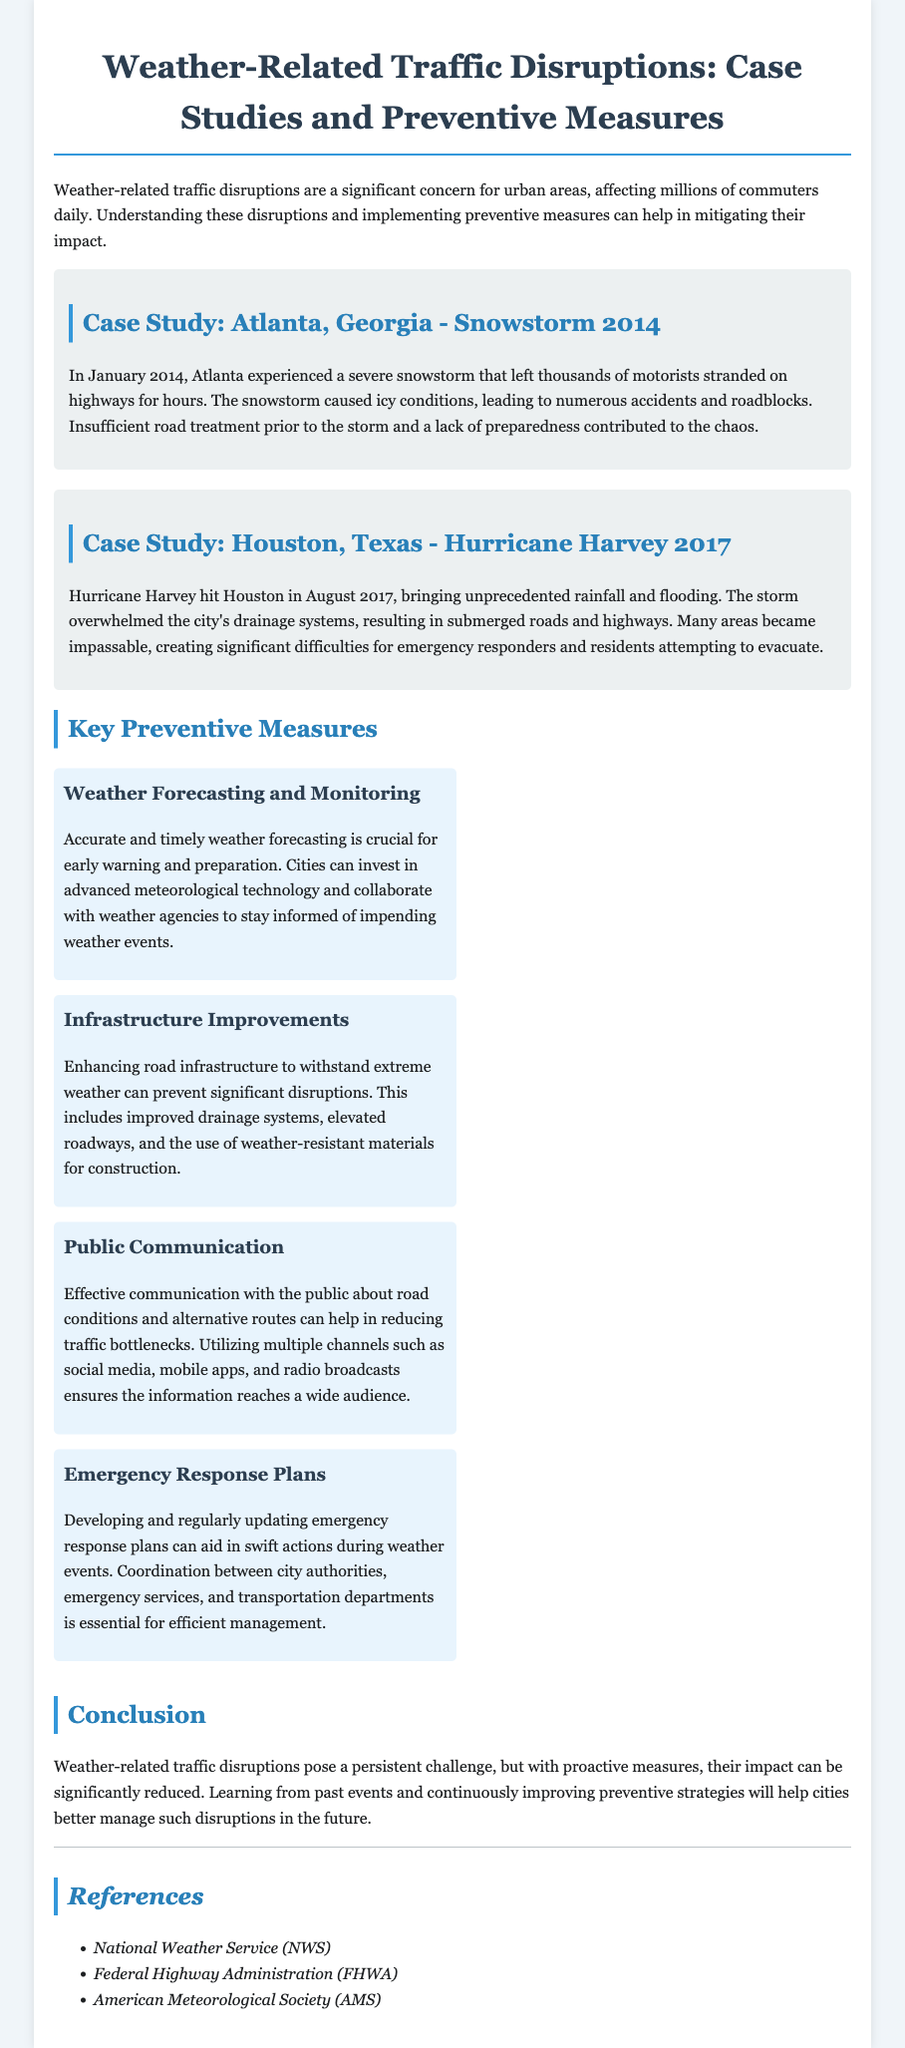what is the title of the report? The title of the report is provided at the beginning of the document.
Answer: Weather-Related Traffic Disruptions: Case Studies and Preventive Measures when did the snowstorm in Atlanta occur? The case study mentions the date when the snowstorm happened.
Answer: January 2014 which hurricane affected Houston in 2017? The document specifies the name of the hurricane that impacted Houston.
Answer: Hurricane Harvey what is one key preventive measure mentioned? The document lists several preventive measures under a specific section.
Answer: Weather Forecasting and Monitoring how did the snowstorm in Atlanta affect motorists? The case study explains the consequences faced by motorists during the snowstorm.
Answer: Stranded on highways what type of improvements can prevent traffic disruptions according to the document? The report discusses enhancements specifically mentioned regarding infrastructure.
Answer: Infrastructure Improvements how can public communication help during weather disruptions? The document highlights the role of communication in managing traffic during adverse conditions.
Answer: Reducing traffic bottlenecks what was overwhelmed during Hurricane Harvey? The report describes a specific system that could not handle the effects of Hurricane Harvey.
Answer: Drainage systems who are some references mentioned in the report? The document lists organizations that provide relevant information in the references section.
Answer: National Weather Service (NWS) 